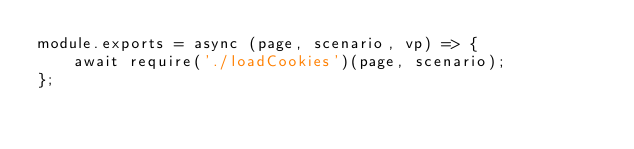<code> <loc_0><loc_0><loc_500><loc_500><_JavaScript_>module.exports = async (page, scenario, vp) => {
    await require('./loadCookies')(page, scenario);
};
</code> 